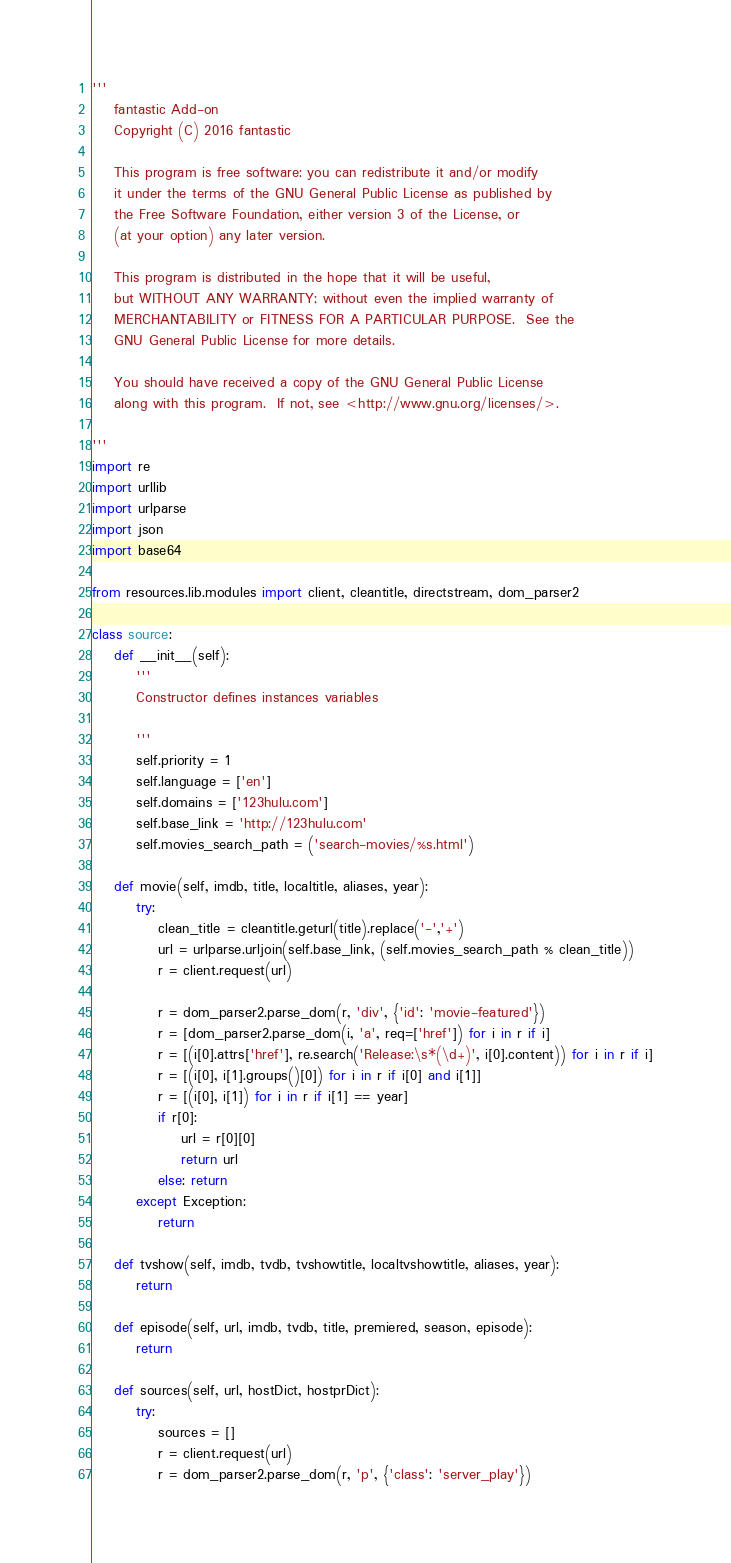Convert code to text. <code><loc_0><loc_0><loc_500><loc_500><_Python_>'''
    fantastic Add-on
    Copyright (C) 2016 fantastic

    This program is free software: you can redistribute it and/or modify
    it under the terms of the GNU General Public License as published by
    the Free Software Foundation, either version 3 of the License, or
    (at your option) any later version.

    This program is distributed in the hope that it will be useful,
    but WITHOUT ANY WARRANTY; without even the implied warranty of
    MERCHANTABILITY or FITNESS FOR A PARTICULAR PURPOSE.  See the
    GNU General Public License for more details.

    You should have received a copy of the GNU General Public License
    along with this program.  If not, see <http://www.gnu.org/licenses/>.

'''
import re
import urllib
import urlparse
import json
import base64

from resources.lib.modules import client, cleantitle, directstream, dom_parser2

class source:
    def __init__(self):
        '''
        Constructor defines instances variables

        '''
        self.priority = 1
        self.language = ['en']
        self.domains = ['123hulu.com']
        self.base_link = 'http://123hulu.com'
        self.movies_search_path = ('search-movies/%s.html')

    def movie(self, imdb, title, localtitle, aliases, year):
        try:
            clean_title = cleantitle.geturl(title).replace('-','+')
            url = urlparse.urljoin(self.base_link, (self.movies_search_path % clean_title))
            r = client.request(url)

            r = dom_parser2.parse_dom(r, 'div', {'id': 'movie-featured'})
            r = [dom_parser2.parse_dom(i, 'a', req=['href']) for i in r if i]
            r = [(i[0].attrs['href'], re.search('Release:\s*(\d+)', i[0].content)) for i in r if i]
            r = [(i[0], i[1].groups()[0]) for i in r if i[0] and i[1]]
            r = [(i[0], i[1]) for i in r if i[1] == year]
            if r[0]: 
                url = r[0][0]
                return url
            else: return
        except Exception:
            return
            
    def tvshow(self, imdb, tvdb, tvshowtitle, localtvshowtitle, aliases, year):
        return

    def episode(self, url, imdb, tvdb, title, premiered, season, episode):
        return

    def sources(self, url, hostDict, hostprDict):
        try:
            sources = []          
            r = client.request(url)
            r = dom_parser2.parse_dom(r, 'p', {'class': 'server_play'})</code> 